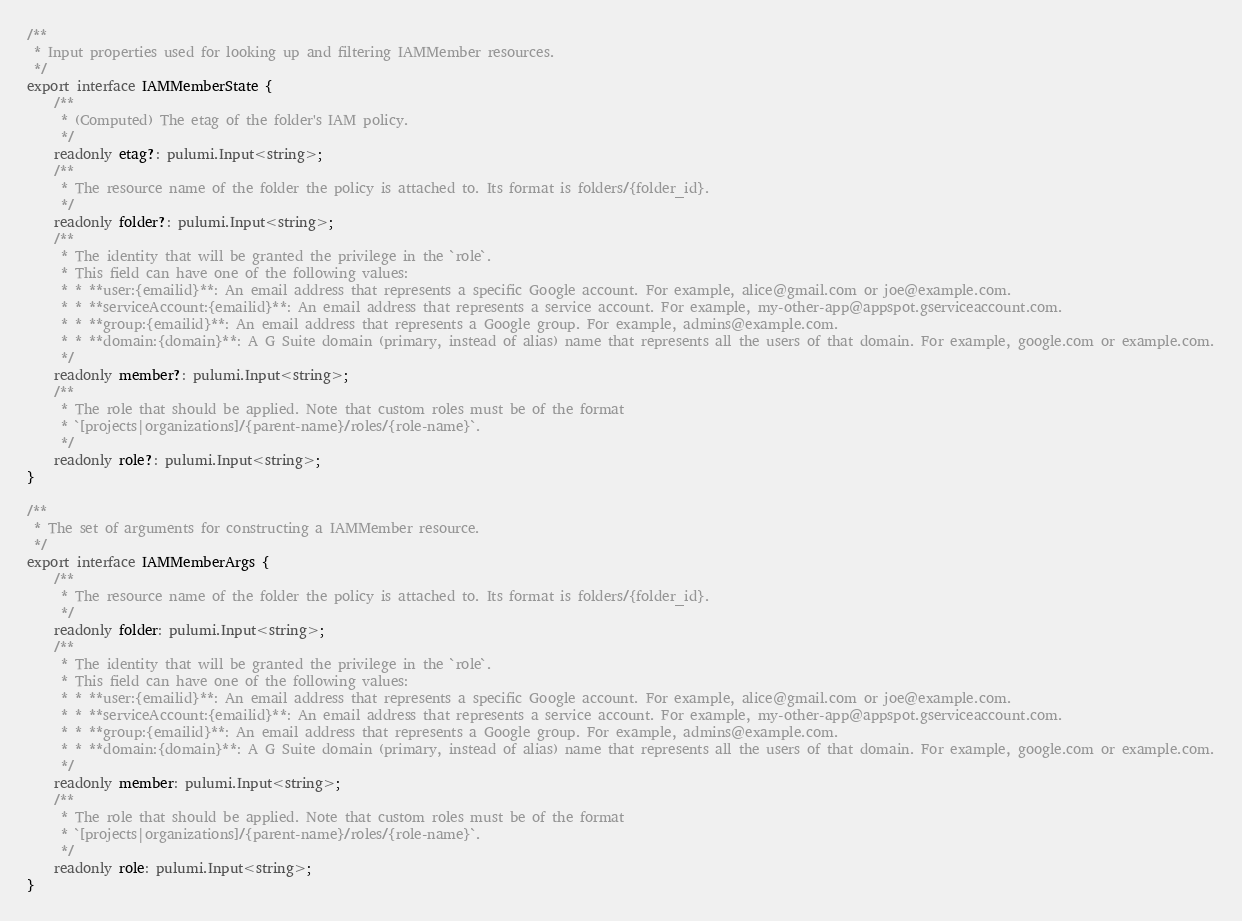Convert code to text. <code><loc_0><loc_0><loc_500><loc_500><_TypeScript_>/**
 * Input properties used for looking up and filtering IAMMember resources.
 */
export interface IAMMemberState {
    /**
     * (Computed) The etag of the folder's IAM policy.
     */
    readonly etag?: pulumi.Input<string>;
    /**
     * The resource name of the folder the policy is attached to. Its format is folders/{folder_id}.
     */
    readonly folder?: pulumi.Input<string>;
    /**
     * The identity that will be granted the privilege in the `role`.
     * This field can have one of the following values:
     * * **user:{emailid}**: An email address that represents a specific Google account. For example, alice@gmail.com or joe@example.com.
     * * **serviceAccount:{emailid}**: An email address that represents a service account. For example, my-other-app@appspot.gserviceaccount.com.
     * * **group:{emailid}**: An email address that represents a Google group. For example, admins@example.com.
     * * **domain:{domain}**: A G Suite domain (primary, instead of alias) name that represents all the users of that domain. For example, google.com or example.com.
     */
    readonly member?: pulumi.Input<string>;
    /**
     * The role that should be applied. Note that custom roles must be of the format
     * `[projects|organizations]/{parent-name}/roles/{role-name}`.
     */
    readonly role?: pulumi.Input<string>;
}

/**
 * The set of arguments for constructing a IAMMember resource.
 */
export interface IAMMemberArgs {
    /**
     * The resource name of the folder the policy is attached to. Its format is folders/{folder_id}.
     */
    readonly folder: pulumi.Input<string>;
    /**
     * The identity that will be granted the privilege in the `role`.
     * This field can have one of the following values:
     * * **user:{emailid}**: An email address that represents a specific Google account. For example, alice@gmail.com or joe@example.com.
     * * **serviceAccount:{emailid}**: An email address that represents a service account. For example, my-other-app@appspot.gserviceaccount.com.
     * * **group:{emailid}**: An email address that represents a Google group. For example, admins@example.com.
     * * **domain:{domain}**: A G Suite domain (primary, instead of alias) name that represents all the users of that domain. For example, google.com or example.com.
     */
    readonly member: pulumi.Input<string>;
    /**
     * The role that should be applied. Note that custom roles must be of the format
     * `[projects|organizations]/{parent-name}/roles/{role-name}`.
     */
    readonly role: pulumi.Input<string>;
}
</code> 